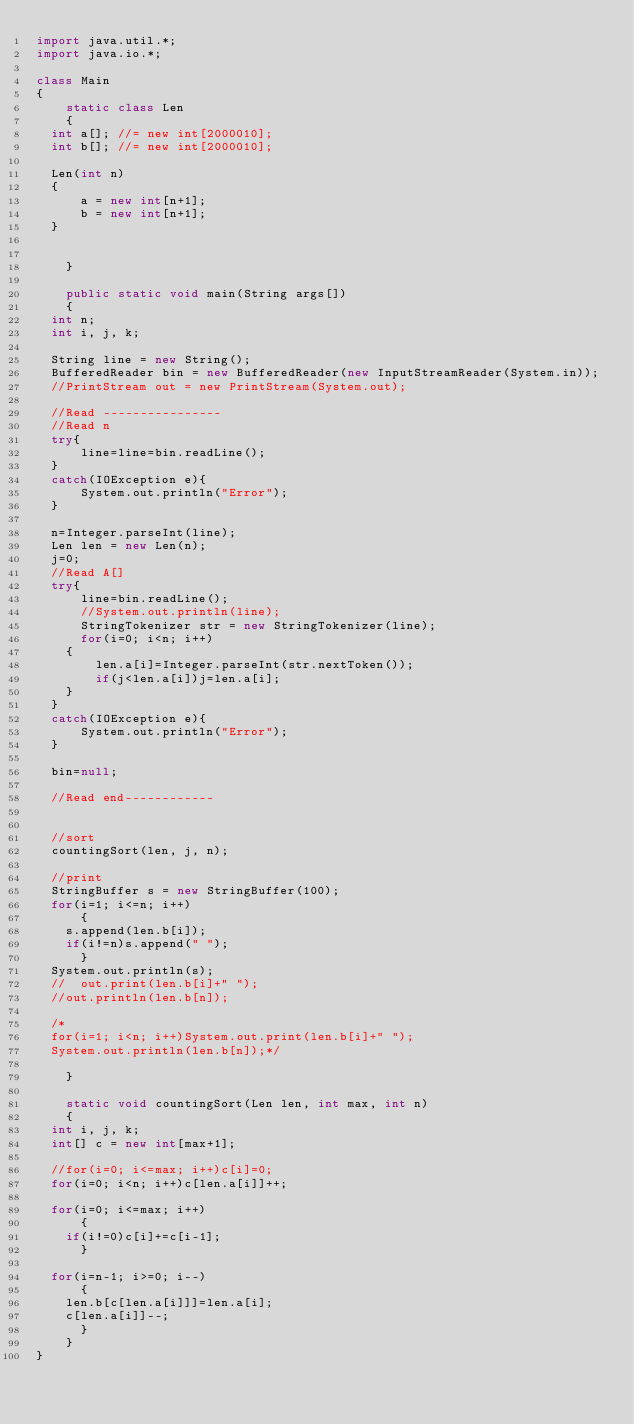Convert code to text. <code><loc_0><loc_0><loc_500><loc_500><_Java_>import java.util.*;
import java.io.*;

class Main
{
    static class Len
    {	
	int a[]; //= new int[2000010];
	int b[]; //= new int[2000010];
	
	Len(int n)
	{
	    a = new int[n+1];
	    b = new int[n+1];
	}
	

    }

    public static void main(String args[])
    {
	int n;
	int i, j, k;

	String line = new String();
	BufferedReader bin = new BufferedReader(new InputStreamReader(System.in));
	//PrintStream out = new PrintStream(System.out);

	//Read ----------------
	//Read n
	try{
	    line=line=bin.readLine();
	}	
	catch(IOException e){
	    System.out.println("Error");
	}

	n=Integer.parseInt(line);
	Len len = new Len(n);
	j=0;
	//Read A[]
	try{
	    line=bin.readLine();
	    //System.out.println(line);
	    StringTokenizer str = new StringTokenizer(line);   
	    for(i=0; i<n; i++)
		{
		    len.a[i]=Integer.parseInt(str.nextToken());
		    if(j<len.a[i])j=len.a[i];
		}
	}
	catch(IOException e){
	    System.out.println("Error");
	}

	bin=null;

	//Read end------------


	//sort
	countingSort(len, j, n);

	//print
	StringBuffer s = new StringBuffer(100);
	for(i=1; i<=n; i++)
	    {
		s.append(len.b[i]);
		if(i!=n)s.append(" ");
	    }
	System.out.println(s);
	//	out.print(len.b[i]+" ");
	//out.println(len.b[n]);

	/*
	for(i=1; i<n; i++)System.out.print(len.b[i]+" ");
	System.out.println(len.b[n]);*/

    }

    static void countingSort(Len len, int max, int n)
    {
	int i, j, k;
	int[] c = new int[max+1];

	//for(i=0; i<=max; i++)c[i]=0;
	for(i=0; i<n; i++)c[len.a[i]]++;

	for(i=0; i<=max; i++)
	    {
		if(i!=0)c[i]+=c[i-1];
	    }

	for(i=n-1; i>=0; i--)
	    {
		len.b[c[len.a[i]]]=len.a[i];
		c[len.a[i]]--;
	    }
    }
}</code> 